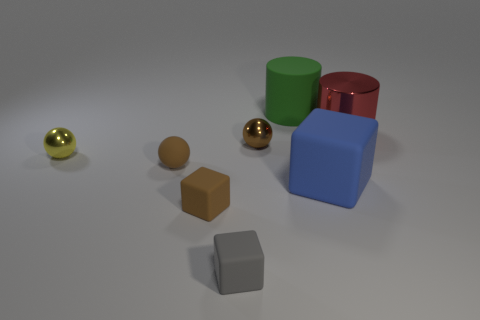There is a big cylinder right of the big rubber thing in front of the green cylinder; are there any gray things that are in front of it?
Ensure brevity in your answer.  Yes. What material is the tiny brown cube that is right of the tiny yellow metal sphere?
Ensure brevity in your answer.  Rubber. Do the brown matte ball and the blue thing have the same size?
Your response must be concise. No. There is a matte object that is in front of the large green object and right of the small gray rubber object; what is its color?
Your response must be concise. Blue. What is the shape of the gray object that is the same material as the large blue thing?
Offer a very short reply. Cube. How many big objects are behind the large block and on the left side of the big red thing?
Ensure brevity in your answer.  1. There is a tiny matte sphere; are there any red cylinders to the right of it?
Your response must be concise. Yes. There is a big matte object on the right side of the green matte object; is it the same shape as the shiny object that is in front of the brown metallic ball?
Your answer should be compact. No. What number of things are either large blue rubber blocks or small brown balls behind the tiny yellow metal thing?
Make the answer very short. 2. What number of other things are there of the same shape as the small yellow metal thing?
Ensure brevity in your answer.  2. 